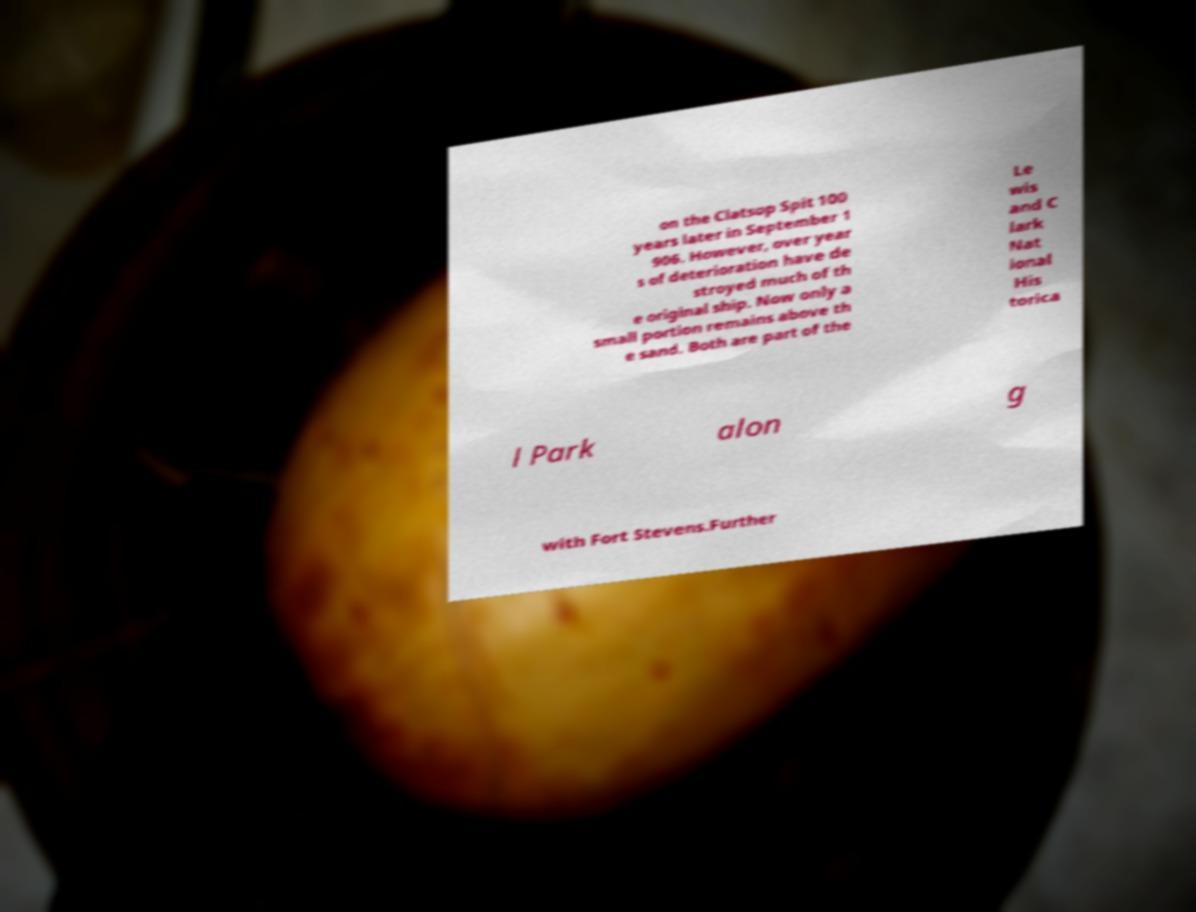Could you extract and type out the text from this image? on the Clatsop Spit 100 years later in September 1 906. However, over year s of deterioration have de stroyed much of th e original ship. Now only a small portion remains above th e sand. Both are part of the Le wis and C lark Nat ional His torica l Park alon g with Fort Stevens.Further 